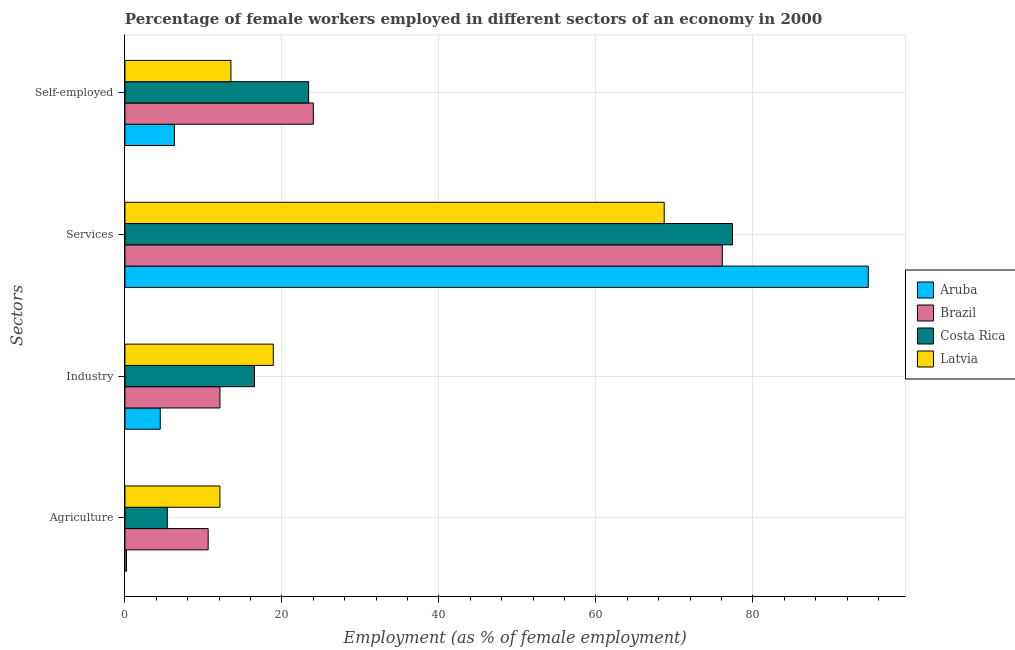How many different coloured bars are there?
Provide a succinct answer. 4. Are the number of bars on each tick of the Y-axis equal?
Give a very brief answer. Yes. How many bars are there on the 2nd tick from the top?
Keep it short and to the point. 4. What is the label of the 2nd group of bars from the top?
Offer a terse response. Services. What is the percentage of female workers in services in Costa Rica?
Your answer should be compact. 77.4. Across all countries, what is the maximum percentage of female workers in industry?
Provide a short and direct response. 18.9. Across all countries, what is the minimum percentage of female workers in agriculture?
Ensure brevity in your answer.  0.2. In which country was the percentage of self employed female workers maximum?
Keep it short and to the point. Brazil. In which country was the percentage of self employed female workers minimum?
Give a very brief answer. Aruba. What is the total percentage of female workers in agriculture in the graph?
Give a very brief answer. 28.3. What is the difference between the percentage of female workers in services in Costa Rica and that in Brazil?
Provide a short and direct response. 1.3. What is the difference between the percentage of self employed female workers in Aruba and the percentage of female workers in industry in Brazil?
Offer a very short reply. -5.8. What is the average percentage of female workers in industry per country?
Your answer should be compact. 13. What is the difference between the percentage of female workers in agriculture and percentage of self employed female workers in Latvia?
Your answer should be compact. -1.4. What is the ratio of the percentage of female workers in agriculture in Brazil to that in Aruba?
Provide a short and direct response. 53. Is the percentage of female workers in services in Costa Rica less than that in Latvia?
Offer a very short reply. No. In how many countries, is the percentage of female workers in industry greater than the average percentage of female workers in industry taken over all countries?
Keep it short and to the point. 2. Is it the case that in every country, the sum of the percentage of female workers in agriculture and percentage of female workers in services is greater than the sum of percentage of female workers in industry and percentage of self employed female workers?
Keep it short and to the point. No. What does the 4th bar from the bottom in Agriculture represents?
Ensure brevity in your answer.  Latvia. How many bars are there?
Give a very brief answer. 16. Are all the bars in the graph horizontal?
Ensure brevity in your answer.  Yes. How many countries are there in the graph?
Your answer should be very brief. 4. Are the values on the major ticks of X-axis written in scientific E-notation?
Ensure brevity in your answer.  No. Where does the legend appear in the graph?
Your answer should be compact. Center right. How many legend labels are there?
Offer a very short reply. 4. How are the legend labels stacked?
Offer a very short reply. Vertical. What is the title of the graph?
Your response must be concise. Percentage of female workers employed in different sectors of an economy in 2000. What is the label or title of the X-axis?
Keep it short and to the point. Employment (as % of female employment). What is the label or title of the Y-axis?
Your answer should be very brief. Sectors. What is the Employment (as % of female employment) in Aruba in Agriculture?
Offer a terse response. 0.2. What is the Employment (as % of female employment) in Brazil in Agriculture?
Give a very brief answer. 10.6. What is the Employment (as % of female employment) of Costa Rica in Agriculture?
Make the answer very short. 5.4. What is the Employment (as % of female employment) of Latvia in Agriculture?
Provide a succinct answer. 12.1. What is the Employment (as % of female employment) in Brazil in Industry?
Give a very brief answer. 12.1. What is the Employment (as % of female employment) of Latvia in Industry?
Offer a terse response. 18.9. What is the Employment (as % of female employment) of Aruba in Services?
Your answer should be compact. 94.7. What is the Employment (as % of female employment) in Brazil in Services?
Ensure brevity in your answer.  76.1. What is the Employment (as % of female employment) of Costa Rica in Services?
Make the answer very short. 77.4. What is the Employment (as % of female employment) of Latvia in Services?
Provide a short and direct response. 68.7. What is the Employment (as % of female employment) of Aruba in Self-employed?
Your answer should be very brief. 6.3. What is the Employment (as % of female employment) of Costa Rica in Self-employed?
Provide a short and direct response. 23.4. What is the Employment (as % of female employment) in Latvia in Self-employed?
Offer a very short reply. 13.5. Across all Sectors, what is the maximum Employment (as % of female employment) of Aruba?
Give a very brief answer. 94.7. Across all Sectors, what is the maximum Employment (as % of female employment) of Brazil?
Ensure brevity in your answer.  76.1. Across all Sectors, what is the maximum Employment (as % of female employment) of Costa Rica?
Make the answer very short. 77.4. Across all Sectors, what is the maximum Employment (as % of female employment) in Latvia?
Make the answer very short. 68.7. Across all Sectors, what is the minimum Employment (as % of female employment) of Aruba?
Offer a very short reply. 0.2. Across all Sectors, what is the minimum Employment (as % of female employment) in Brazil?
Ensure brevity in your answer.  10.6. Across all Sectors, what is the minimum Employment (as % of female employment) in Costa Rica?
Provide a succinct answer. 5.4. Across all Sectors, what is the minimum Employment (as % of female employment) in Latvia?
Your answer should be very brief. 12.1. What is the total Employment (as % of female employment) of Aruba in the graph?
Your answer should be very brief. 105.7. What is the total Employment (as % of female employment) in Brazil in the graph?
Offer a very short reply. 122.8. What is the total Employment (as % of female employment) in Costa Rica in the graph?
Offer a very short reply. 122.7. What is the total Employment (as % of female employment) in Latvia in the graph?
Offer a very short reply. 113.2. What is the difference between the Employment (as % of female employment) in Latvia in Agriculture and that in Industry?
Provide a succinct answer. -6.8. What is the difference between the Employment (as % of female employment) in Aruba in Agriculture and that in Services?
Make the answer very short. -94.5. What is the difference between the Employment (as % of female employment) in Brazil in Agriculture and that in Services?
Your answer should be very brief. -65.5. What is the difference between the Employment (as % of female employment) of Costa Rica in Agriculture and that in Services?
Give a very brief answer. -72. What is the difference between the Employment (as % of female employment) in Latvia in Agriculture and that in Services?
Make the answer very short. -56.6. What is the difference between the Employment (as % of female employment) in Brazil in Agriculture and that in Self-employed?
Your response must be concise. -13.4. What is the difference between the Employment (as % of female employment) of Costa Rica in Agriculture and that in Self-employed?
Your answer should be very brief. -18. What is the difference between the Employment (as % of female employment) of Latvia in Agriculture and that in Self-employed?
Give a very brief answer. -1.4. What is the difference between the Employment (as % of female employment) of Aruba in Industry and that in Services?
Provide a short and direct response. -90.2. What is the difference between the Employment (as % of female employment) of Brazil in Industry and that in Services?
Ensure brevity in your answer.  -64. What is the difference between the Employment (as % of female employment) of Costa Rica in Industry and that in Services?
Your response must be concise. -60.9. What is the difference between the Employment (as % of female employment) in Latvia in Industry and that in Services?
Keep it short and to the point. -49.8. What is the difference between the Employment (as % of female employment) in Aruba in Industry and that in Self-employed?
Your answer should be very brief. -1.8. What is the difference between the Employment (as % of female employment) in Brazil in Industry and that in Self-employed?
Offer a very short reply. -11.9. What is the difference between the Employment (as % of female employment) in Latvia in Industry and that in Self-employed?
Your answer should be very brief. 5.4. What is the difference between the Employment (as % of female employment) in Aruba in Services and that in Self-employed?
Provide a succinct answer. 88.4. What is the difference between the Employment (as % of female employment) of Brazil in Services and that in Self-employed?
Your answer should be very brief. 52.1. What is the difference between the Employment (as % of female employment) in Costa Rica in Services and that in Self-employed?
Your answer should be very brief. 54. What is the difference between the Employment (as % of female employment) of Latvia in Services and that in Self-employed?
Keep it short and to the point. 55.2. What is the difference between the Employment (as % of female employment) in Aruba in Agriculture and the Employment (as % of female employment) in Brazil in Industry?
Your answer should be very brief. -11.9. What is the difference between the Employment (as % of female employment) of Aruba in Agriculture and the Employment (as % of female employment) of Costa Rica in Industry?
Offer a very short reply. -16.3. What is the difference between the Employment (as % of female employment) of Aruba in Agriculture and the Employment (as % of female employment) of Latvia in Industry?
Make the answer very short. -18.7. What is the difference between the Employment (as % of female employment) of Brazil in Agriculture and the Employment (as % of female employment) of Costa Rica in Industry?
Offer a very short reply. -5.9. What is the difference between the Employment (as % of female employment) in Brazil in Agriculture and the Employment (as % of female employment) in Latvia in Industry?
Ensure brevity in your answer.  -8.3. What is the difference between the Employment (as % of female employment) of Costa Rica in Agriculture and the Employment (as % of female employment) of Latvia in Industry?
Your answer should be compact. -13.5. What is the difference between the Employment (as % of female employment) in Aruba in Agriculture and the Employment (as % of female employment) in Brazil in Services?
Keep it short and to the point. -75.9. What is the difference between the Employment (as % of female employment) of Aruba in Agriculture and the Employment (as % of female employment) of Costa Rica in Services?
Your answer should be very brief. -77.2. What is the difference between the Employment (as % of female employment) of Aruba in Agriculture and the Employment (as % of female employment) of Latvia in Services?
Your response must be concise. -68.5. What is the difference between the Employment (as % of female employment) of Brazil in Agriculture and the Employment (as % of female employment) of Costa Rica in Services?
Offer a very short reply. -66.8. What is the difference between the Employment (as % of female employment) of Brazil in Agriculture and the Employment (as % of female employment) of Latvia in Services?
Provide a short and direct response. -58.1. What is the difference between the Employment (as % of female employment) of Costa Rica in Agriculture and the Employment (as % of female employment) of Latvia in Services?
Your response must be concise. -63.3. What is the difference between the Employment (as % of female employment) in Aruba in Agriculture and the Employment (as % of female employment) in Brazil in Self-employed?
Provide a short and direct response. -23.8. What is the difference between the Employment (as % of female employment) in Aruba in Agriculture and the Employment (as % of female employment) in Costa Rica in Self-employed?
Ensure brevity in your answer.  -23.2. What is the difference between the Employment (as % of female employment) of Brazil in Agriculture and the Employment (as % of female employment) of Latvia in Self-employed?
Your answer should be compact. -2.9. What is the difference between the Employment (as % of female employment) of Aruba in Industry and the Employment (as % of female employment) of Brazil in Services?
Give a very brief answer. -71.6. What is the difference between the Employment (as % of female employment) in Aruba in Industry and the Employment (as % of female employment) in Costa Rica in Services?
Your response must be concise. -72.9. What is the difference between the Employment (as % of female employment) in Aruba in Industry and the Employment (as % of female employment) in Latvia in Services?
Give a very brief answer. -64.2. What is the difference between the Employment (as % of female employment) of Brazil in Industry and the Employment (as % of female employment) of Costa Rica in Services?
Give a very brief answer. -65.3. What is the difference between the Employment (as % of female employment) of Brazil in Industry and the Employment (as % of female employment) of Latvia in Services?
Provide a succinct answer. -56.6. What is the difference between the Employment (as % of female employment) in Costa Rica in Industry and the Employment (as % of female employment) in Latvia in Services?
Offer a terse response. -52.2. What is the difference between the Employment (as % of female employment) of Aruba in Industry and the Employment (as % of female employment) of Brazil in Self-employed?
Keep it short and to the point. -19.5. What is the difference between the Employment (as % of female employment) of Aruba in Industry and the Employment (as % of female employment) of Costa Rica in Self-employed?
Your answer should be compact. -18.9. What is the difference between the Employment (as % of female employment) of Aruba in Industry and the Employment (as % of female employment) of Latvia in Self-employed?
Make the answer very short. -9. What is the difference between the Employment (as % of female employment) in Brazil in Industry and the Employment (as % of female employment) in Costa Rica in Self-employed?
Provide a short and direct response. -11.3. What is the difference between the Employment (as % of female employment) in Brazil in Industry and the Employment (as % of female employment) in Latvia in Self-employed?
Offer a very short reply. -1.4. What is the difference between the Employment (as % of female employment) in Costa Rica in Industry and the Employment (as % of female employment) in Latvia in Self-employed?
Make the answer very short. 3. What is the difference between the Employment (as % of female employment) of Aruba in Services and the Employment (as % of female employment) of Brazil in Self-employed?
Your answer should be very brief. 70.7. What is the difference between the Employment (as % of female employment) of Aruba in Services and the Employment (as % of female employment) of Costa Rica in Self-employed?
Provide a short and direct response. 71.3. What is the difference between the Employment (as % of female employment) in Aruba in Services and the Employment (as % of female employment) in Latvia in Self-employed?
Make the answer very short. 81.2. What is the difference between the Employment (as % of female employment) in Brazil in Services and the Employment (as % of female employment) in Costa Rica in Self-employed?
Your answer should be compact. 52.7. What is the difference between the Employment (as % of female employment) in Brazil in Services and the Employment (as % of female employment) in Latvia in Self-employed?
Your answer should be very brief. 62.6. What is the difference between the Employment (as % of female employment) of Costa Rica in Services and the Employment (as % of female employment) of Latvia in Self-employed?
Give a very brief answer. 63.9. What is the average Employment (as % of female employment) of Aruba per Sectors?
Keep it short and to the point. 26.43. What is the average Employment (as % of female employment) of Brazil per Sectors?
Your response must be concise. 30.7. What is the average Employment (as % of female employment) of Costa Rica per Sectors?
Your answer should be very brief. 30.68. What is the average Employment (as % of female employment) of Latvia per Sectors?
Provide a short and direct response. 28.3. What is the difference between the Employment (as % of female employment) of Aruba and Employment (as % of female employment) of Costa Rica in Agriculture?
Your answer should be very brief. -5.2. What is the difference between the Employment (as % of female employment) in Brazil and Employment (as % of female employment) in Costa Rica in Agriculture?
Make the answer very short. 5.2. What is the difference between the Employment (as % of female employment) of Costa Rica and Employment (as % of female employment) of Latvia in Agriculture?
Keep it short and to the point. -6.7. What is the difference between the Employment (as % of female employment) of Aruba and Employment (as % of female employment) of Latvia in Industry?
Give a very brief answer. -14.4. What is the difference between the Employment (as % of female employment) of Brazil and Employment (as % of female employment) of Costa Rica in Industry?
Make the answer very short. -4.4. What is the difference between the Employment (as % of female employment) in Brazil and Employment (as % of female employment) in Latvia in Industry?
Ensure brevity in your answer.  -6.8. What is the difference between the Employment (as % of female employment) in Aruba and Employment (as % of female employment) in Brazil in Services?
Your response must be concise. 18.6. What is the difference between the Employment (as % of female employment) in Aruba and Employment (as % of female employment) in Latvia in Services?
Ensure brevity in your answer.  26. What is the difference between the Employment (as % of female employment) of Brazil and Employment (as % of female employment) of Costa Rica in Services?
Provide a short and direct response. -1.3. What is the difference between the Employment (as % of female employment) in Costa Rica and Employment (as % of female employment) in Latvia in Services?
Provide a succinct answer. 8.7. What is the difference between the Employment (as % of female employment) of Aruba and Employment (as % of female employment) of Brazil in Self-employed?
Make the answer very short. -17.7. What is the difference between the Employment (as % of female employment) in Aruba and Employment (as % of female employment) in Costa Rica in Self-employed?
Keep it short and to the point. -17.1. What is the difference between the Employment (as % of female employment) of Aruba and Employment (as % of female employment) of Latvia in Self-employed?
Make the answer very short. -7.2. What is the difference between the Employment (as % of female employment) of Brazil and Employment (as % of female employment) of Latvia in Self-employed?
Offer a very short reply. 10.5. What is the ratio of the Employment (as % of female employment) in Aruba in Agriculture to that in Industry?
Your response must be concise. 0.04. What is the ratio of the Employment (as % of female employment) of Brazil in Agriculture to that in Industry?
Offer a very short reply. 0.88. What is the ratio of the Employment (as % of female employment) of Costa Rica in Agriculture to that in Industry?
Your response must be concise. 0.33. What is the ratio of the Employment (as % of female employment) of Latvia in Agriculture to that in Industry?
Offer a very short reply. 0.64. What is the ratio of the Employment (as % of female employment) in Aruba in Agriculture to that in Services?
Give a very brief answer. 0. What is the ratio of the Employment (as % of female employment) of Brazil in Agriculture to that in Services?
Your answer should be very brief. 0.14. What is the ratio of the Employment (as % of female employment) in Costa Rica in Agriculture to that in Services?
Offer a terse response. 0.07. What is the ratio of the Employment (as % of female employment) of Latvia in Agriculture to that in Services?
Provide a short and direct response. 0.18. What is the ratio of the Employment (as % of female employment) of Aruba in Agriculture to that in Self-employed?
Provide a succinct answer. 0.03. What is the ratio of the Employment (as % of female employment) in Brazil in Agriculture to that in Self-employed?
Offer a terse response. 0.44. What is the ratio of the Employment (as % of female employment) of Costa Rica in Agriculture to that in Self-employed?
Provide a succinct answer. 0.23. What is the ratio of the Employment (as % of female employment) of Latvia in Agriculture to that in Self-employed?
Ensure brevity in your answer.  0.9. What is the ratio of the Employment (as % of female employment) of Aruba in Industry to that in Services?
Provide a succinct answer. 0.05. What is the ratio of the Employment (as % of female employment) of Brazil in Industry to that in Services?
Ensure brevity in your answer.  0.16. What is the ratio of the Employment (as % of female employment) of Costa Rica in Industry to that in Services?
Provide a succinct answer. 0.21. What is the ratio of the Employment (as % of female employment) of Latvia in Industry to that in Services?
Ensure brevity in your answer.  0.28. What is the ratio of the Employment (as % of female employment) in Brazil in Industry to that in Self-employed?
Ensure brevity in your answer.  0.5. What is the ratio of the Employment (as % of female employment) of Costa Rica in Industry to that in Self-employed?
Offer a very short reply. 0.71. What is the ratio of the Employment (as % of female employment) in Latvia in Industry to that in Self-employed?
Your answer should be compact. 1.4. What is the ratio of the Employment (as % of female employment) of Aruba in Services to that in Self-employed?
Your answer should be very brief. 15.03. What is the ratio of the Employment (as % of female employment) of Brazil in Services to that in Self-employed?
Your answer should be compact. 3.17. What is the ratio of the Employment (as % of female employment) of Costa Rica in Services to that in Self-employed?
Offer a terse response. 3.31. What is the ratio of the Employment (as % of female employment) of Latvia in Services to that in Self-employed?
Keep it short and to the point. 5.09. What is the difference between the highest and the second highest Employment (as % of female employment) of Aruba?
Your answer should be compact. 88.4. What is the difference between the highest and the second highest Employment (as % of female employment) in Brazil?
Provide a short and direct response. 52.1. What is the difference between the highest and the second highest Employment (as % of female employment) of Latvia?
Your answer should be very brief. 49.8. What is the difference between the highest and the lowest Employment (as % of female employment) in Aruba?
Make the answer very short. 94.5. What is the difference between the highest and the lowest Employment (as % of female employment) of Brazil?
Offer a terse response. 65.5. What is the difference between the highest and the lowest Employment (as % of female employment) of Costa Rica?
Offer a very short reply. 72. What is the difference between the highest and the lowest Employment (as % of female employment) of Latvia?
Keep it short and to the point. 56.6. 